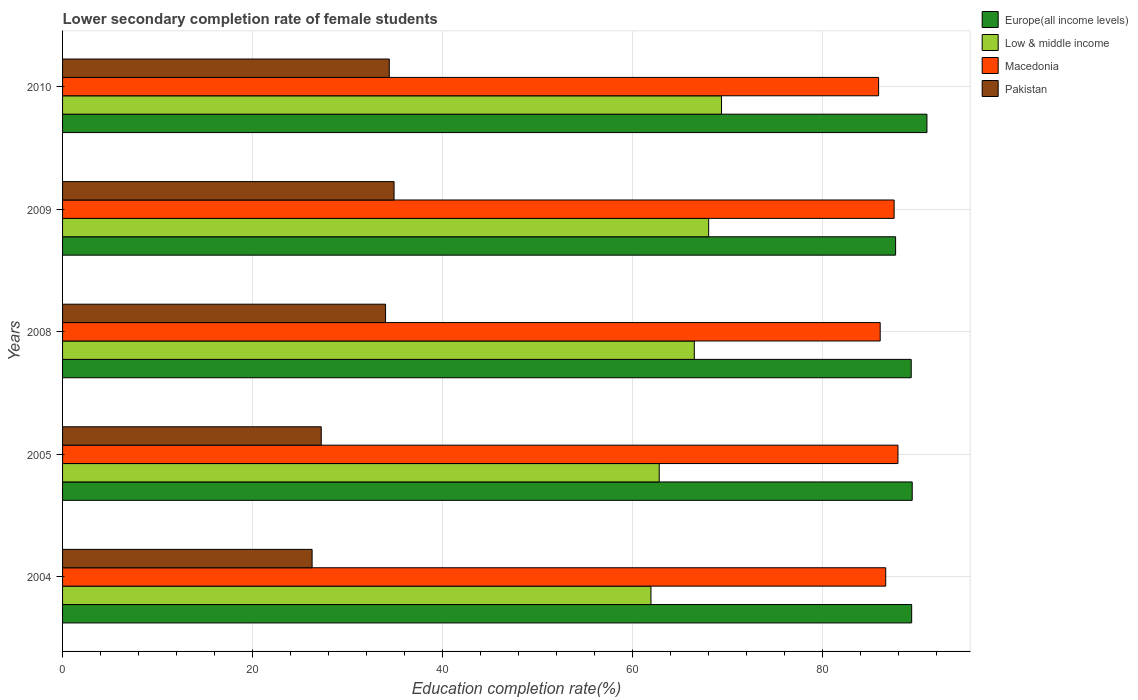How many different coloured bars are there?
Offer a very short reply. 4. How many groups of bars are there?
Your answer should be very brief. 5. Are the number of bars on each tick of the Y-axis equal?
Your answer should be compact. Yes. In how many cases, is the number of bars for a given year not equal to the number of legend labels?
Provide a succinct answer. 0. What is the lower secondary completion rate of female students in Pakistan in 2010?
Your response must be concise. 34.38. Across all years, what is the maximum lower secondary completion rate of female students in Macedonia?
Your answer should be very brief. 87.91. Across all years, what is the minimum lower secondary completion rate of female students in Low & middle income?
Provide a short and direct response. 61.92. In which year was the lower secondary completion rate of female students in Europe(all income levels) minimum?
Give a very brief answer. 2009. What is the total lower secondary completion rate of female students in Low & middle income in the graph?
Your answer should be very brief. 328.52. What is the difference between the lower secondary completion rate of female students in Macedonia in 2008 and that in 2009?
Your response must be concise. -1.47. What is the difference between the lower secondary completion rate of female students in Macedonia in 2004 and the lower secondary completion rate of female students in Pakistan in 2005?
Your answer should be very brief. 59.4. What is the average lower secondary completion rate of female students in Europe(all income levels) per year?
Offer a very short reply. 89.34. In the year 2010, what is the difference between the lower secondary completion rate of female students in Europe(all income levels) and lower secondary completion rate of female students in Macedonia?
Provide a succinct answer. 5.09. In how many years, is the lower secondary completion rate of female students in Europe(all income levels) greater than 44 %?
Offer a very short reply. 5. What is the ratio of the lower secondary completion rate of female students in Europe(all income levels) in 2004 to that in 2005?
Your response must be concise. 1. Is the difference between the lower secondary completion rate of female students in Europe(all income levels) in 2005 and 2008 greater than the difference between the lower secondary completion rate of female students in Macedonia in 2005 and 2008?
Offer a terse response. No. What is the difference between the highest and the second highest lower secondary completion rate of female students in Pakistan?
Ensure brevity in your answer.  0.5. What is the difference between the highest and the lowest lower secondary completion rate of female students in Macedonia?
Ensure brevity in your answer.  2.04. What does the 4th bar from the top in 2005 represents?
Provide a succinct answer. Europe(all income levels). Are all the bars in the graph horizontal?
Offer a terse response. Yes. How many years are there in the graph?
Your answer should be very brief. 5. Are the values on the major ticks of X-axis written in scientific E-notation?
Make the answer very short. No. Does the graph contain any zero values?
Your answer should be very brief. No. Does the graph contain grids?
Your answer should be very brief. Yes. Where does the legend appear in the graph?
Ensure brevity in your answer.  Top right. How many legend labels are there?
Ensure brevity in your answer.  4. How are the legend labels stacked?
Give a very brief answer. Vertical. What is the title of the graph?
Your answer should be very brief. Lower secondary completion rate of female students. Does "Cayman Islands" appear as one of the legend labels in the graph?
Your answer should be very brief. No. What is the label or title of the X-axis?
Keep it short and to the point. Education completion rate(%). What is the label or title of the Y-axis?
Your answer should be compact. Years. What is the Education completion rate(%) in Europe(all income levels) in 2004?
Provide a succinct answer. 89.35. What is the Education completion rate(%) of Low & middle income in 2004?
Your answer should be compact. 61.92. What is the Education completion rate(%) of Macedonia in 2004?
Provide a short and direct response. 86.62. What is the Education completion rate(%) in Pakistan in 2004?
Keep it short and to the point. 26.26. What is the Education completion rate(%) in Europe(all income levels) in 2005?
Make the answer very short. 89.41. What is the Education completion rate(%) of Low & middle income in 2005?
Keep it short and to the point. 62.79. What is the Education completion rate(%) in Macedonia in 2005?
Keep it short and to the point. 87.91. What is the Education completion rate(%) in Pakistan in 2005?
Provide a short and direct response. 27.22. What is the Education completion rate(%) in Europe(all income levels) in 2008?
Provide a succinct answer. 89.31. What is the Education completion rate(%) of Low & middle income in 2008?
Make the answer very short. 66.48. What is the Education completion rate(%) of Macedonia in 2008?
Ensure brevity in your answer.  86.04. What is the Education completion rate(%) of Pakistan in 2008?
Provide a succinct answer. 33.99. What is the Education completion rate(%) in Europe(all income levels) in 2009?
Your answer should be very brief. 87.66. What is the Education completion rate(%) in Low & middle income in 2009?
Your answer should be very brief. 67.99. What is the Education completion rate(%) of Macedonia in 2009?
Provide a succinct answer. 87.51. What is the Education completion rate(%) in Pakistan in 2009?
Give a very brief answer. 34.88. What is the Education completion rate(%) in Europe(all income levels) in 2010?
Ensure brevity in your answer.  90.96. What is the Education completion rate(%) in Low & middle income in 2010?
Provide a short and direct response. 69.34. What is the Education completion rate(%) of Macedonia in 2010?
Your answer should be compact. 85.87. What is the Education completion rate(%) in Pakistan in 2010?
Provide a short and direct response. 34.38. Across all years, what is the maximum Education completion rate(%) of Europe(all income levels)?
Provide a succinct answer. 90.96. Across all years, what is the maximum Education completion rate(%) in Low & middle income?
Give a very brief answer. 69.34. Across all years, what is the maximum Education completion rate(%) of Macedonia?
Give a very brief answer. 87.91. Across all years, what is the maximum Education completion rate(%) of Pakistan?
Make the answer very short. 34.88. Across all years, what is the minimum Education completion rate(%) of Europe(all income levels)?
Offer a very short reply. 87.66. Across all years, what is the minimum Education completion rate(%) in Low & middle income?
Ensure brevity in your answer.  61.92. Across all years, what is the minimum Education completion rate(%) of Macedonia?
Your answer should be very brief. 85.87. Across all years, what is the minimum Education completion rate(%) in Pakistan?
Your answer should be very brief. 26.26. What is the total Education completion rate(%) in Europe(all income levels) in the graph?
Ensure brevity in your answer.  446.69. What is the total Education completion rate(%) in Low & middle income in the graph?
Provide a short and direct response. 328.52. What is the total Education completion rate(%) in Macedonia in the graph?
Your answer should be compact. 433.95. What is the total Education completion rate(%) in Pakistan in the graph?
Give a very brief answer. 156.74. What is the difference between the Education completion rate(%) in Europe(all income levels) in 2004 and that in 2005?
Keep it short and to the point. -0.06. What is the difference between the Education completion rate(%) in Low & middle income in 2004 and that in 2005?
Make the answer very short. -0.87. What is the difference between the Education completion rate(%) of Macedonia in 2004 and that in 2005?
Make the answer very short. -1.29. What is the difference between the Education completion rate(%) of Pakistan in 2004 and that in 2005?
Your response must be concise. -0.96. What is the difference between the Education completion rate(%) in Europe(all income levels) in 2004 and that in 2008?
Your answer should be compact. 0.05. What is the difference between the Education completion rate(%) in Low & middle income in 2004 and that in 2008?
Ensure brevity in your answer.  -4.56. What is the difference between the Education completion rate(%) of Macedonia in 2004 and that in 2008?
Provide a succinct answer. 0.58. What is the difference between the Education completion rate(%) in Pakistan in 2004 and that in 2008?
Offer a very short reply. -7.73. What is the difference between the Education completion rate(%) of Europe(all income levels) in 2004 and that in 2009?
Your response must be concise. 1.69. What is the difference between the Education completion rate(%) in Low & middle income in 2004 and that in 2009?
Your answer should be very brief. -6.07. What is the difference between the Education completion rate(%) in Macedonia in 2004 and that in 2009?
Your response must be concise. -0.88. What is the difference between the Education completion rate(%) of Pakistan in 2004 and that in 2009?
Your answer should be very brief. -8.62. What is the difference between the Education completion rate(%) in Europe(all income levels) in 2004 and that in 2010?
Offer a very short reply. -1.61. What is the difference between the Education completion rate(%) of Low & middle income in 2004 and that in 2010?
Give a very brief answer. -7.42. What is the difference between the Education completion rate(%) of Macedonia in 2004 and that in 2010?
Your answer should be compact. 0.75. What is the difference between the Education completion rate(%) of Pakistan in 2004 and that in 2010?
Make the answer very short. -8.12. What is the difference between the Education completion rate(%) of Europe(all income levels) in 2005 and that in 2008?
Ensure brevity in your answer.  0.11. What is the difference between the Education completion rate(%) in Low & middle income in 2005 and that in 2008?
Keep it short and to the point. -3.69. What is the difference between the Education completion rate(%) in Macedonia in 2005 and that in 2008?
Offer a very short reply. 1.87. What is the difference between the Education completion rate(%) of Pakistan in 2005 and that in 2008?
Keep it short and to the point. -6.77. What is the difference between the Education completion rate(%) in Europe(all income levels) in 2005 and that in 2009?
Your response must be concise. 1.75. What is the difference between the Education completion rate(%) in Low & middle income in 2005 and that in 2009?
Provide a succinct answer. -5.2. What is the difference between the Education completion rate(%) in Macedonia in 2005 and that in 2009?
Ensure brevity in your answer.  0.4. What is the difference between the Education completion rate(%) of Pakistan in 2005 and that in 2009?
Provide a succinct answer. -7.66. What is the difference between the Education completion rate(%) in Europe(all income levels) in 2005 and that in 2010?
Give a very brief answer. -1.55. What is the difference between the Education completion rate(%) of Low & middle income in 2005 and that in 2010?
Your answer should be very brief. -6.55. What is the difference between the Education completion rate(%) of Macedonia in 2005 and that in 2010?
Provide a succinct answer. 2.04. What is the difference between the Education completion rate(%) in Pakistan in 2005 and that in 2010?
Offer a very short reply. -7.16. What is the difference between the Education completion rate(%) of Europe(all income levels) in 2008 and that in 2009?
Provide a short and direct response. 1.64. What is the difference between the Education completion rate(%) of Low & middle income in 2008 and that in 2009?
Provide a short and direct response. -1.51. What is the difference between the Education completion rate(%) in Macedonia in 2008 and that in 2009?
Your answer should be compact. -1.47. What is the difference between the Education completion rate(%) of Pakistan in 2008 and that in 2009?
Offer a very short reply. -0.9. What is the difference between the Education completion rate(%) of Europe(all income levels) in 2008 and that in 2010?
Make the answer very short. -1.66. What is the difference between the Education completion rate(%) of Low & middle income in 2008 and that in 2010?
Give a very brief answer. -2.86. What is the difference between the Education completion rate(%) of Macedonia in 2008 and that in 2010?
Provide a short and direct response. 0.17. What is the difference between the Education completion rate(%) in Pakistan in 2008 and that in 2010?
Give a very brief answer. -0.39. What is the difference between the Education completion rate(%) in Europe(all income levels) in 2009 and that in 2010?
Provide a succinct answer. -3.3. What is the difference between the Education completion rate(%) in Low & middle income in 2009 and that in 2010?
Ensure brevity in your answer.  -1.35. What is the difference between the Education completion rate(%) of Macedonia in 2009 and that in 2010?
Provide a succinct answer. 1.63. What is the difference between the Education completion rate(%) in Pakistan in 2009 and that in 2010?
Your answer should be compact. 0.5. What is the difference between the Education completion rate(%) of Europe(all income levels) in 2004 and the Education completion rate(%) of Low & middle income in 2005?
Your answer should be compact. 26.57. What is the difference between the Education completion rate(%) of Europe(all income levels) in 2004 and the Education completion rate(%) of Macedonia in 2005?
Your answer should be very brief. 1.44. What is the difference between the Education completion rate(%) in Europe(all income levels) in 2004 and the Education completion rate(%) in Pakistan in 2005?
Provide a succinct answer. 62.13. What is the difference between the Education completion rate(%) of Low & middle income in 2004 and the Education completion rate(%) of Macedonia in 2005?
Provide a short and direct response. -25.99. What is the difference between the Education completion rate(%) of Low & middle income in 2004 and the Education completion rate(%) of Pakistan in 2005?
Provide a succinct answer. 34.7. What is the difference between the Education completion rate(%) in Macedonia in 2004 and the Education completion rate(%) in Pakistan in 2005?
Provide a succinct answer. 59.4. What is the difference between the Education completion rate(%) in Europe(all income levels) in 2004 and the Education completion rate(%) in Low & middle income in 2008?
Your answer should be compact. 22.87. What is the difference between the Education completion rate(%) of Europe(all income levels) in 2004 and the Education completion rate(%) of Macedonia in 2008?
Your response must be concise. 3.31. What is the difference between the Education completion rate(%) of Europe(all income levels) in 2004 and the Education completion rate(%) of Pakistan in 2008?
Your response must be concise. 55.36. What is the difference between the Education completion rate(%) in Low & middle income in 2004 and the Education completion rate(%) in Macedonia in 2008?
Make the answer very short. -24.12. What is the difference between the Education completion rate(%) in Low & middle income in 2004 and the Education completion rate(%) in Pakistan in 2008?
Provide a succinct answer. 27.93. What is the difference between the Education completion rate(%) of Macedonia in 2004 and the Education completion rate(%) of Pakistan in 2008?
Give a very brief answer. 52.63. What is the difference between the Education completion rate(%) of Europe(all income levels) in 2004 and the Education completion rate(%) of Low & middle income in 2009?
Your answer should be compact. 21.36. What is the difference between the Education completion rate(%) in Europe(all income levels) in 2004 and the Education completion rate(%) in Macedonia in 2009?
Offer a very short reply. 1.85. What is the difference between the Education completion rate(%) in Europe(all income levels) in 2004 and the Education completion rate(%) in Pakistan in 2009?
Your answer should be very brief. 54.47. What is the difference between the Education completion rate(%) of Low & middle income in 2004 and the Education completion rate(%) of Macedonia in 2009?
Give a very brief answer. -25.59. What is the difference between the Education completion rate(%) in Low & middle income in 2004 and the Education completion rate(%) in Pakistan in 2009?
Your answer should be very brief. 27.03. What is the difference between the Education completion rate(%) in Macedonia in 2004 and the Education completion rate(%) in Pakistan in 2009?
Provide a short and direct response. 51.74. What is the difference between the Education completion rate(%) of Europe(all income levels) in 2004 and the Education completion rate(%) of Low & middle income in 2010?
Keep it short and to the point. 20.01. What is the difference between the Education completion rate(%) of Europe(all income levels) in 2004 and the Education completion rate(%) of Macedonia in 2010?
Your answer should be very brief. 3.48. What is the difference between the Education completion rate(%) in Europe(all income levels) in 2004 and the Education completion rate(%) in Pakistan in 2010?
Make the answer very short. 54.97. What is the difference between the Education completion rate(%) of Low & middle income in 2004 and the Education completion rate(%) of Macedonia in 2010?
Make the answer very short. -23.96. What is the difference between the Education completion rate(%) in Low & middle income in 2004 and the Education completion rate(%) in Pakistan in 2010?
Make the answer very short. 27.54. What is the difference between the Education completion rate(%) of Macedonia in 2004 and the Education completion rate(%) of Pakistan in 2010?
Make the answer very short. 52.24. What is the difference between the Education completion rate(%) in Europe(all income levels) in 2005 and the Education completion rate(%) in Low & middle income in 2008?
Keep it short and to the point. 22.93. What is the difference between the Education completion rate(%) of Europe(all income levels) in 2005 and the Education completion rate(%) of Macedonia in 2008?
Your response must be concise. 3.37. What is the difference between the Education completion rate(%) of Europe(all income levels) in 2005 and the Education completion rate(%) of Pakistan in 2008?
Your response must be concise. 55.42. What is the difference between the Education completion rate(%) of Low & middle income in 2005 and the Education completion rate(%) of Macedonia in 2008?
Make the answer very short. -23.25. What is the difference between the Education completion rate(%) in Low & middle income in 2005 and the Education completion rate(%) in Pakistan in 2008?
Offer a very short reply. 28.8. What is the difference between the Education completion rate(%) in Macedonia in 2005 and the Education completion rate(%) in Pakistan in 2008?
Your answer should be very brief. 53.92. What is the difference between the Education completion rate(%) of Europe(all income levels) in 2005 and the Education completion rate(%) of Low & middle income in 2009?
Keep it short and to the point. 21.42. What is the difference between the Education completion rate(%) of Europe(all income levels) in 2005 and the Education completion rate(%) of Macedonia in 2009?
Provide a succinct answer. 1.91. What is the difference between the Education completion rate(%) of Europe(all income levels) in 2005 and the Education completion rate(%) of Pakistan in 2009?
Your answer should be compact. 54.53. What is the difference between the Education completion rate(%) in Low & middle income in 2005 and the Education completion rate(%) in Macedonia in 2009?
Keep it short and to the point. -24.72. What is the difference between the Education completion rate(%) in Low & middle income in 2005 and the Education completion rate(%) in Pakistan in 2009?
Provide a succinct answer. 27.9. What is the difference between the Education completion rate(%) of Macedonia in 2005 and the Education completion rate(%) of Pakistan in 2009?
Give a very brief answer. 53.03. What is the difference between the Education completion rate(%) in Europe(all income levels) in 2005 and the Education completion rate(%) in Low & middle income in 2010?
Offer a very short reply. 20.07. What is the difference between the Education completion rate(%) in Europe(all income levels) in 2005 and the Education completion rate(%) in Macedonia in 2010?
Ensure brevity in your answer.  3.54. What is the difference between the Education completion rate(%) of Europe(all income levels) in 2005 and the Education completion rate(%) of Pakistan in 2010?
Ensure brevity in your answer.  55.03. What is the difference between the Education completion rate(%) in Low & middle income in 2005 and the Education completion rate(%) in Macedonia in 2010?
Make the answer very short. -23.09. What is the difference between the Education completion rate(%) in Low & middle income in 2005 and the Education completion rate(%) in Pakistan in 2010?
Give a very brief answer. 28.41. What is the difference between the Education completion rate(%) in Macedonia in 2005 and the Education completion rate(%) in Pakistan in 2010?
Offer a terse response. 53.53. What is the difference between the Education completion rate(%) in Europe(all income levels) in 2008 and the Education completion rate(%) in Low & middle income in 2009?
Your answer should be very brief. 21.32. What is the difference between the Education completion rate(%) of Europe(all income levels) in 2008 and the Education completion rate(%) of Macedonia in 2009?
Give a very brief answer. 1.8. What is the difference between the Education completion rate(%) in Europe(all income levels) in 2008 and the Education completion rate(%) in Pakistan in 2009?
Your answer should be compact. 54.42. What is the difference between the Education completion rate(%) in Low & middle income in 2008 and the Education completion rate(%) in Macedonia in 2009?
Your answer should be very brief. -21.03. What is the difference between the Education completion rate(%) of Low & middle income in 2008 and the Education completion rate(%) of Pakistan in 2009?
Your answer should be compact. 31.59. What is the difference between the Education completion rate(%) of Macedonia in 2008 and the Education completion rate(%) of Pakistan in 2009?
Your response must be concise. 51.16. What is the difference between the Education completion rate(%) of Europe(all income levels) in 2008 and the Education completion rate(%) of Low & middle income in 2010?
Your response must be concise. 19.96. What is the difference between the Education completion rate(%) of Europe(all income levels) in 2008 and the Education completion rate(%) of Macedonia in 2010?
Offer a terse response. 3.43. What is the difference between the Education completion rate(%) of Europe(all income levels) in 2008 and the Education completion rate(%) of Pakistan in 2010?
Your response must be concise. 54.92. What is the difference between the Education completion rate(%) in Low & middle income in 2008 and the Education completion rate(%) in Macedonia in 2010?
Give a very brief answer. -19.39. What is the difference between the Education completion rate(%) of Low & middle income in 2008 and the Education completion rate(%) of Pakistan in 2010?
Provide a short and direct response. 32.1. What is the difference between the Education completion rate(%) of Macedonia in 2008 and the Education completion rate(%) of Pakistan in 2010?
Your answer should be compact. 51.66. What is the difference between the Education completion rate(%) in Europe(all income levels) in 2009 and the Education completion rate(%) in Low & middle income in 2010?
Your response must be concise. 18.32. What is the difference between the Education completion rate(%) of Europe(all income levels) in 2009 and the Education completion rate(%) of Macedonia in 2010?
Your response must be concise. 1.79. What is the difference between the Education completion rate(%) in Europe(all income levels) in 2009 and the Education completion rate(%) in Pakistan in 2010?
Provide a short and direct response. 53.28. What is the difference between the Education completion rate(%) in Low & middle income in 2009 and the Education completion rate(%) in Macedonia in 2010?
Make the answer very short. -17.88. What is the difference between the Education completion rate(%) of Low & middle income in 2009 and the Education completion rate(%) of Pakistan in 2010?
Offer a terse response. 33.61. What is the difference between the Education completion rate(%) of Macedonia in 2009 and the Education completion rate(%) of Pakistan in 2010?
Your answer should be compact. 53.13. What is the average Education completion rate(%) in Europe(all income levels) per year?
Make the answer very short. 89.34. What is the average Education completion rate(%) in Low & middle income per year?
Keep it short and to the point. 65.7. What is the average Education completion rate(%) of Macedonia per year?
Provide a short and direct response. 86.79. What is the average Education completion rate(%) of Pakistan per year?
Your answer should be very brief. 31.35. In the year 2004, what is the difference between the Education completion rate(%) of Europe(all income levels) and Education completion rate(%) of Low & middle income?
Give a very brief answer. 27.44. In the year 2004, what is the difference between the Education completion rate(%) in Europe(all income levels) and Education completion rate(%) in Macedonia?
Your response must be concise. 2.73. In the year 2004, what is the difference between the Education completion rate(%) in Europe(all income levels) and Education completion rate(%) in Pakistan?
Give a very brief answer. 63.09. In the year 2004, what is the difference between the Education completion rate(%) of Low & middle income and Education completion rate(%) of Macedonia?
Give a very brief answer. -24.7. In the year 2004, what is the difference between the Education completion rate(%) in Low & middle income and Education completion rate(%) in Pakistan?
Offer a very short reply. 35.66. In the year 2004, what is the difference between the Education completion rate(%) in Macedonia and Education completion rate(%) in Pakistan?
Give a very brief answer. 60.36. In the year 2005, what is the difference between the Education completion rate(%) of Europe(all income levels) and Education completion rate(%) of Low & middle income?
Provide a succinct answer. 26.62. In the year 2005, what is the difference between the Education completion rate(%) of Europe(all income levels) and Education completion rate(%) of Macedonia?
Keep it short and to the point. 1.5. In the year 2005, what is the difference between the Education completion rate(%) in Europe(all income levels) and Education completion rate(%) in Pakistan?
Provide a succinct answer. 62.19. In the year 2005, what is the difference between the Education completion rate(%) in Low & middle income and Education completion rate(%) in Macedonia?
Ensure brevity in your answer.  -25.12. In the year 2005, what is the difference between the Education completion rate(%) in Low & middle income and Education completion rate(%) in Pakistan?
Your answer should be compact. 35.57. In the year 2005, what is the difference between the Education completion rate(%) in Macedonia and Education completion rate(%) in Pakistan?
Provide a short and direct response. 60.69. In the year 2008, what is the difference between the Education completion rate(%) in Europe(all income levels) and Education completion rate(%) in Low & middle income?
Offer a terse response. 22.83. In the year 2008, what is the difference between the Education completion rate(%) in Europe(all income levels) and Education completion rate(%) in Macedonia?
Your response must be concise. 3.26. In the year 2008, what is the difference between the Education completion rate(%) in Europe(all income levels) and Education completion rate(%) in Pakistan?
Ensure brevity in your answer.  55.32. In the year 2008, what is the difference between the Education completion rate(%) in Low & middle income and Education completion rate(%) in Macedonia?
Keep it short and to the point. -19.56. In the year 2008, what is the difference between the Education completion rate(%) of Low & middle income and Education completion rate(%) of Pakistan?
Your answer should be compact. 32.49. In the year 2008, what is the difference between the Education completion rate(%) in Macedonia and Education completion rate(%) in Pakistan?
Offer a terse response. 52.05. In the year 2009, what is the difference between the Education completion rate(%) in Europe(all income levels) and Education completion rate(%) in Low & middle income?
Provide a succinct answer. 19.67. In the year 2009, what is the difference between the Education completion rate(%) in Europe(all income levels) and Education completion rate(%) in Macedonia?
Your answer should be very brief. 0.16. In the year 2009, what is the difference between the Education completion rate(%) in Europe(all income levels) and Education completion rate(%) in Pakistan?
Provide a succinct answer. 52.78. In the year 2009, what is the difference between the Education completion rate(%) of Low & middle income and Education completion rate(%) of Macedonia?
Keep it short and to the point. -19.52. In the year 2009, what is the difference between the Education completion rate(%) in Low & middle income and Education completion rate(%) in Pakistan?
Offer a terse response. 33.1. In the year 2009, what is the difference between the Education completion rate(%) of Macedonia and Education completion rate(%) of Pakistan?
Give a very brief answer. 52.62. In the year 2010, what is the difference between the Education completion rate(%) of Europe(all income levels) and Education completion rate(%) of Low & middle income?
Ensure brevity in your answer.  21.62. In the year 2010, what is the difference between the Education completion rate(%) of Europe(all income levels) and Education completion rate(%) of Macedonia?
Give a very brief answer. 5.09. In the year 2010, what is the difference between the Education completion rate(%) of Europe(all income levels) and Education completion rate(%) of Pakistan?
Give a very brief answer. 56.58. In the year 2010, what is the difference between the Education completion rate(%) of Low & middle income and Education completion rate(%) of Macedonia?
Provide a succinct answer. -16.53. In the year 2010, what is the difference between the Education completion rate(%) in Low & middle income and Education completion rate(%) in Pakistan?
Ensure brevity in your answer.  34.96. In the year 2010, what is the difference between the Education completion rate(%) in Macedonia and Education completion rate(%) in Pakistan?
Give a very brief answer. 51.49. What is the ratio of the Education completion rate(%) of Europe(all income levels) in 2004 to that in 2005?
Provide a short and direct response. 1. What is the ratio of the Education completion rate(%) in Low & middle income in 2004 to that in 2005?
Provide a short and direct response. 0.99. What is the ratio of the Education completion rate(%) in Pakistan in 2004 to that in 2005?
Your answer should be compact. 0.96. What is the ratio of the Education completion rate(%) in Europe(all income levels) in 2004 to that in 2008?
Ensure brevity in your answer.  1. What is the ratio of the Education completion rate(%) of Low & middle income in 2004 to that in 2008?
Make the answer very short. 0.93. What is the ratio of the Education completion rate(%) of Macedonia in 2004 to that in 2008?
Offer a terse response. 1.01. What is the ratio of the Education completion rate(%) of Pakistan in 2004 to that in 2008?
Make the answer very short. 0.77. What is the ratio of the Education completion rate(%) in Europe(all income levels) in 2004 to that in 2009?
Make the answer very short. 1.02. What is the ratio of the Education completion rate(%) of Low & middle income in 2004 to that in 2009?
Ensure brevity in your answer.  0.91. What is the ratio of the Education completion rate(%) in Macedonia in 2004 to that in 2009?
Provide a short and direct response. 0.99. What is the ratio of the Education completion rate(%) of Pakistan in 2004 to that in 2009?
Your answer should be compact. 0.75. What is the ratio of the Education completion rate(%) of Europe(all income levels) in 2004 to that in 2010?
Offer a very short reply. 0.98. What is the ratio of the Education completion rate(%) in Low & middle income in 2004 to that in 2010?
Give a very brief answer. 0.89. What is the ratio of the Education completion rate(%) of Macedonia in 2004 to that in 2010?
Your answer should be very brief. 1.01. What is the ratio of the Education completion rate(%) of Pakistan in 2004 to that in 2010?
Provide a succinct answer. 0.76. What is the ratio of the Education completion rate(%) in Europe(all income levels) in 2005 to that in 2008?
Ensure brevity in your answer.  1. What is the ratio of the Education completion rate(%) of Low & middle income in 2005 to that in 2008?
Offer a very short reply. 0.94. What is the ratio of the Education completion rate(%) of Macedonia in 2005 to that in 2008?
Make the answer very short. 1.02. What is the ratio of the Education completion rate(%) in Pakistan in 2005 to that in 2008?
Offer a terse response. 0.8. What is the ratio of the Education completion rate(%) in Europe(all income levels) in 2005 to that in 2009?
Make the answer very short. 1.02. What is the ratio of the Education completion rate(%) in Low & middle income in 2005 to that in 2009?
Your answer should be very brief. 0.92. What is the ratio of the Education completion rate(%) of Macedonia in 2005 to that in 2009?
Provide a short and direct response. 1. What is the ratio of the Education completion rate(%) of Pakistan in 2005 to that in 2009?
Your answer should be very brief. 0.78. What is the ratio of the Education completion rate(%) in Low & middle income in 2005 to that in 2010?
Your response must be concise. 0.91. What is the ratio of the Education completion rate(%) of Macedonia in 2005 to that in 2010?
Provide a succinct answer. 1.02. What is the ratio of the Education completion rate(%) of Pakistan in 2005 to that in 2010?
Your answer should be very brief. 0.79. What is the ratio of the Education completion rate(%) of Europe(all income levels) in 2008 to that in 2009?
Offer a terse response. 1.02. What is the ratio of the Education completion rate(%) in Low & middle income in 2008 to that in 2009?
Your answer should be very brief. 0.98. What is the ratio of the Education completion rate(%) in Macedonia in 2008 to that in 2009?
Keep it short and to the point. 0.98. What is the ratio of the Education completion rate(%) of Pakistan in 2008 to that in 2009?
Offer a terse response. 0.97. What is the ratio of the Education completion rate(%) of Europe(all income levels) in 2008 to that in 2010?
Offer a terse response. 0.98. What is the ratio of the Education completion rate(%) in Low & middle income in 2008 to that in 2010?
Your answer should be compact. 0.96. What is the ratio of the Education completion rate(%) of Pakistan in 2008 to that in 2010?
Ensure brevity in your answer.  0.99. What is the ratio of the Education completion rate(%) of Europe(all income levels) in 2009 to that in 2010?
Give a very brief answer. 0.96. What is the ratio of the Education completion rate(%) in Low & middle income in 2009 to that in 2010?
Keep it short and to the point. 0.98. What is the ratio of the Education completion rate(%) of Macedonia in 2009 to that in 2010?
Your answer should be very brief. 1.02. What is the ratio of the Education completion rate(%) in Pakistan in 2009 to that in 2010?
Keep it short and to the point. 1.01. What is the difference between the highest and the second highest Education completion rate(%) in Europe(all income levels)?
Your response must be concise. 1.55. What is the difference between the highest and the second highest Education completion rate(%) of Low & middle income?
Keep it short and to the point. 1.35. What is the difference between the highest and the second highest Education completion rate(%) of Macedonia?
Provide a short and direct response. 0.4. What is the difference between the highest and the second highest Education completion rate(%) in Pakistan?
Make the answer very short. 0.5. What is the difference between the highest and the lowest Education completion rate(%) of Europe(all income levels)?
Provide a succinct answer. 3.3. What is the difference between the highest and the lowest Education completion rate(%) in Low & middle income?
Your response must be concise. 7.42. What is the difference between the highest and the lowest Education completion rate(%) of Macedonia?
Your answer should be very brief. 2.04. What is the difference between the highest and the lowest Education completion rate(%) in Pakistan?
Give a very brief answer. 8.62. 